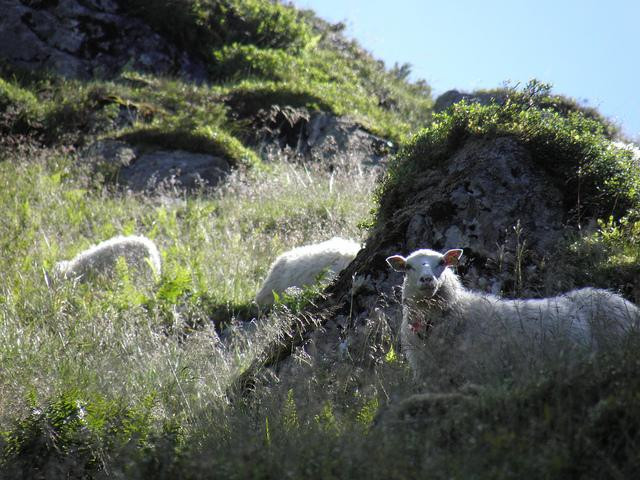What part of the animal on the right is visible? head 